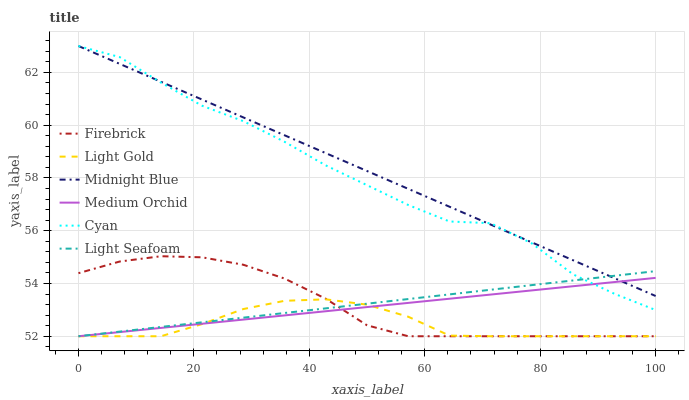Does Light Gold have the minimum area under the curve?
Answer yes or no. Yes. Does Midnight Blue have the maximum area under the curve?
Answer yes or no. Yes. Does Firebrick have the minimum area under the curve?
Answer yes or no. No. Does Firebrick have the maximum area under the curve?
Answer yes or no. No. Is Light Seafoam the smoothest?
Answer yes or no. Yes. Is Cyan the roughest?
Answer yes or no. Yes. Is Firebrick the smoothest?
Answer yes or no. No. Is Firebrick the roughest?
Answer yes or no. No. Does Firebrick have the lowest value?
Answer yes or no. Yes. Does Cyan have the lowest value?
Answer yes or no. No. Does Cyan have the highest value?
Answer yes or no. Yes. Does Firebrick have the highest value?
Answer yes or no. No. Is Light Gold less than Cyan?
Answer yes or no. Yes. Is Cyan greater than Light Gold?
Answer yes or no. Yes. Does Midnight Blue intersect Medium Orchid?
Answer yes or no. Yes. Is Midnight Blue less than Medium Orchid?
Answer yes or no. No. Is Midnight Blue greater than Medium Orchid?
Answer yes or no. No. Does Light Gold intersect Cyan?
Answer yes or no. No. 